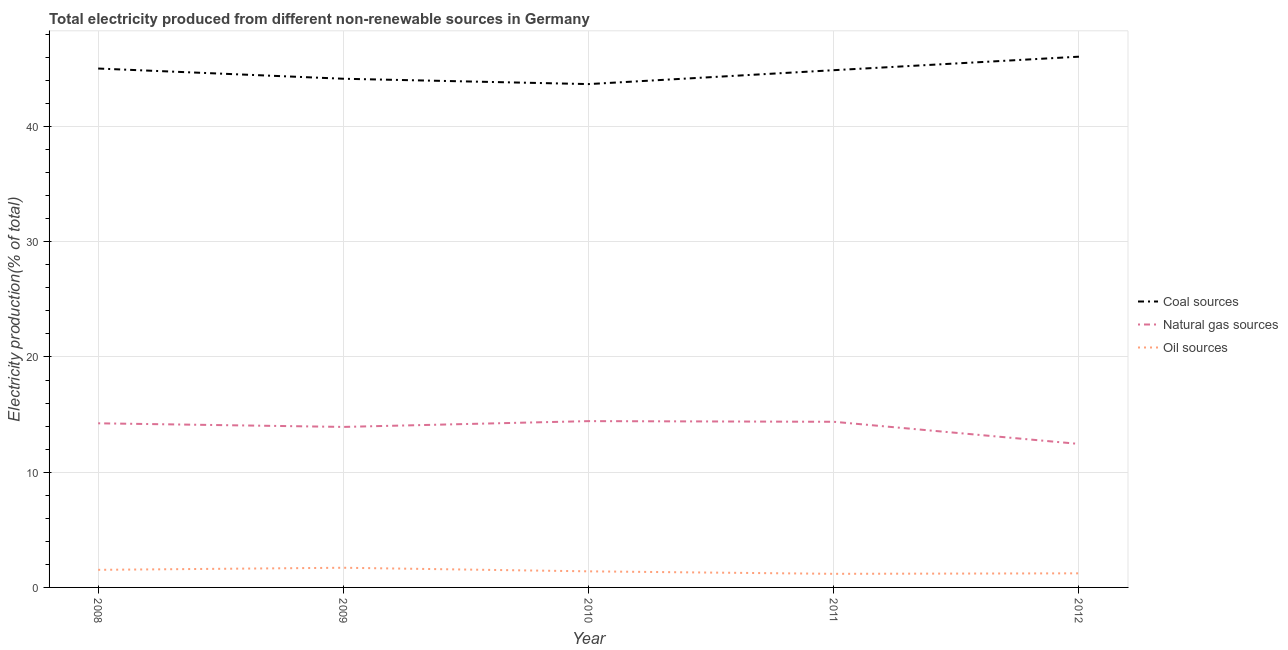Does the line corresponding to percentage of electricity produced by natural gas intersect with the line corresponding to percentage of electricity produced by oil sources?
Ensure brevity in your answer.  No. What is the percentage of electricity produced by natural gas in 2009?
Give a very brief answer. 13.93. Across all years, what is the maximum percentage of electricity produced by oil sources?
Provide a short and direct response. 1.71. Across all years, what is the minimum percentage of electricity produced by coal?
Keep it short and to the point. 43.68. In which year was the percentage of electricity produced by coal maximum?
Keep it short and to the point. 2012. What is the total percentage of electricity produced by natural gas in the graph?
Offer a very short reply. 69.43. What is the difference between the percentage of electricity produced by natural gas in 2009 and that in 2012?
Your answer should be very brief. 1.48. What is the difference between the percentage of electricity produced by coal in 2008 and the percentage of electricity produced by natural gas in 2009?
Keep it short and to the point. 31.1. What is the average percentage of electricity produced by coal per year?
Provide a succinct answer. 44.76. In the year 2012, what is the difference between the percentage of electricity produced by natural gas and percentage of electricity produced by coal?
Ensure brevity in your answer.  -33.6. What is the ratio of the percentage of electricity produced by coal in 2009 to that in 2010?
Your answer should be compact. 1.01. What is the difference between the highest and the second highest percentage of electricity produced by oil sources?
Keep it short and to the point. 0.18. What is the difference between the highest and the lowest percentage of electricity produced by natural gas?
Your response must be concise. 1.98. Is it the case that in every year, the sum of the percentage of electricity produced by coal and percentage of electricity produced by natural gas is greater than the percentage of electricity produced by oil sources?
Your answer should be very brief. Yes. How many years are there in the graph?
Make the answer very short. 5. What is the difference between two consecutive major ticks on the Y-axis?
Ensure brevity in your answer.  10. What is the title of the graph?
Offer a terse response. Total electricity produced from different non-renewable sources in Germany. Does "Services" appear as one of the legend labels in the graph?
Offer a very short reply. No. What is the label or title of the Y-axis?
Make the answer very short. Electricity production(% of total). What is the Electricity production(% of total) in Coal sources in 2008?
Offer a very short reply. 45.03. What is the Electricity production(% of total) of Natural gas sources in 2008?
Ensure brevity in your answer.  14.24. What is the Electricity production(% of total) of Oil sources in 2008?
Your answer should be very brief. 1.53. What is the Electricity production(% of total) of Coal sources in 2009?
Ensure brevity in your answer.  44.14. What is the Electricity production(% of total) in Natural gas sources in 2009?
Ensure brevity in your answer.  13.93. What is the Electricity production(% of total) in Oil sources in 2009?
Provide a succinct answer. 1.71. What is the Electricity production(% of total) in Coal sources in 2010?
Keep it short and to the point. 43.68. What is the Electricity production(% of total) in Natural gas sources in 2010?
Ensure brevity in your answer.  14.43. What is the Electricity production(% of total) in Oil sources in 2010?
Ensure brevity in your answer.  1.4. What is the Electricity production(% of total) in Coal sources in 2011?
Give a very brief answer. 44.89. What is the Electricity production(% of total) in Natural gas sources in 2011?
Provide a short and direct response. 14.37. What is the Electricity production(% of total) in Oil sources in 2011?
Your response must be concise. 1.18. What is the Electricity production(% of total) in Coal sources in 2012?
Give a very brief answer. 46.06. What is the Electricity production(% of total) in Natural gas sources in 2012?
Your answer should be very brief. 12.45. What is the Electricity production(% of total) in Oil sources in 2012?
Provide a short and direct response. 1.22. Across all years, what is the maximum Electricity production(% of total) of Coal sources?
Your answer should be compact. 46.06. Across all years, what is the maximum Electricity production(% of total) of Natural gas sources?
Provide a succinct answer. 14.43. Across all years, what is the maximum Electricity production(% of total) in Oil sources?
Offer a very short reply. 1.71. Across all years, what is the minimum Electricity production(% of total) in Coal sources?
Keep it short and to the point. 43.68. Across all years, what is the minimum Electricity production(% of total) of Natural gas sources?
Make the answer very short. 12.45. Across all years, what is the minimum Electricity production(% of total) in Oil sources?
Ensure brevity in your answer.  1.18. What is the total Electricity production(% of total) of Coal sources in the graph?
Your answer should be compact. 223.8. What is the total Electricity production(% of total) of Natural gas sources in the graph?
Your answer should be very brief. 69.43. What is the total Electricity production(% of total) in Oil sources in the graph?
Provide a succinct answer. 7.03. What is the difference between the Electricity production(% of total) of Coal sources in 2008 and that in 2009?
Provide a succinct answer. 0.89. What is the difference between the Electricity production(% of total) in Natural gas sources in 2008 and that in 2009?
Keep it short and to the point. 0.31. What is the difference between the Electricity production(% of total) of Oil sources in 2008 and that in 2009?
Offer a terse response. -0.18. What is the difference between the Electricity production(% of total) in Coal sources in 2008 and that in 2010?
Offer a very short reply. 1.35. What is the difference between the Electricity production(% of total) in Natural gas sources in 2008 and that in 2010?
Your answer should be very brief. -0.19. What is the difference between the Electricity production(% of total) of Oil sources in 2008 and that in 2010?
Keep it short and to the point. 0.13. What is the difference between the Electricity production(% of total) in Coal sources in 2008 and that in 2011?
Make the answer very short. 0.14. What is the difference between the Electricity production(% of total) of Natural gas sources in 2008 and that in 2011?
Your response must be concise. -0.13. What is the difference between the Electricity production(% of total) of Oil sources in 2008 and that in 2011?
Your response must be concise. 0.35. What is the difference between the Electricity production(% of total) in Coal sources in 2008 and that in 2012?
Make the answer very short. -1.03. What is the difference between the Electricity production(% of total) of Natural gas sources in 2008 and that in 2012?
Ensure brevity in your answer.  1.79. What is the difference between the Electricity production(% of total) of Oil sources in 2008 and that in 2012?
Offer a very short reply. 0.3. What is the difference between the Electricity production(% of total) in Coal sources in 2009 and that in 2010?
Your response must be concise. 0.46. What is the difference between the Electricity production(% of total) in Natural gas sources in 2009 and that in 2010?
Give a very brief answer. -0.5. What is the difference between the Electricity production(% of total) of Oil sources in 2009 and that in 2010?
Keep it short and to the point. 0.31. What is the difference between the Electricity production(% of total) of Coal sources in 2009 and that in 2011?
Offer a very short reply. -0.74. What is the difference between the Electricity production(% of total) in Natural gas sources in 2009 and that in 2011?
Provide a succinct answer. -0.45. What is the difference between the Electricity production(% of total) in Oil sources in 2009 and that in 2011?
Provide a short and direct response. 0.53. What is the difference between the Electricity production(% of total) of Coal sources in 2009 and that in 2012?
Keep it short and to the point. -1.91. What is the difference between the Electricity production(% of total) in Natural gas sources in 2009 and that in 2012?
Offer a very short reply. 1.48. What is the difference between the Electricity production(% of total) in Oil sources in 2009 and that in 2012?
Give a very brief answer. 0.48. What is the difference between the Electricity production(% of total) in Coal sources in 2010 and that in 2011?
Keep it short and to the point. -1.21. What is the difference between the Electricity production(% of total) of Natural gas sources in 2010 and that in 2011?
Provide a short and direct response. 0.06. What is the difference between the Electricity production(% of total) in Oil sources in 2010 and that in 2011?
Provide a short and direct response. 0.22. What is the difference between the Electricity production(% of total) in Coal sources in 2010 and that in 2012?
Make the answer very short. -2.38. What is the difference between the Electricity production(% of total) of Natural gas sources in 2010 and that in 2012?
Give a very brief answer. 1.98. What is the difference between the Electricity production(% of total) in Oil sources in 2010 and that in 2012?
Offer a terse response. 0.17. What is the difference between the Electricity production(% of total) in Coal sources in 2011 and that in 2012?
Your answer should be very brief. -1.17. What is the difference between the Electricity production(% of total) of Natural gas sources in 2011 and that in 2012?
Provide a short and direct response. 1.92. What is the difference between the Electricity production(% of total) of Oil sources in 2011 and that in 2012?
Offer a terse response. -0.04. What is the difference between the Electricity production(% of total) in Coal sources in 2008 and the Electricity production(% of total) in Natural gas sources in 2009?
Keep it short and to the point. 31.1. What is the difference between the Electricity production(% of total) in Coal sources in 2008 and the Electricity production(% of total) in Oil sources in 2009?
Keep it short and to the point. 43.32. What is the difference between the Electricity production(% of total) in Natural gas sources in 2008 and the Electricity production(% of total) in Oil sources in 2009?
Provide a succinct answer. 12.54. What is the difference between the Electricity production(% of total) in Coal sources in 2008 and the Electricity production(% of total) in Natural gas sources in 2010?
Offer a terse response. 30.6. What is the difference between the Electricity production(% of total) of Coal sources in 2008 and the Electricity production(% of total) of Oil sources in 2010?
Keep it short and to the point. 43.63. What is the difference between the Electricity production(% of total) in Natural gas sources in 2008 and the Electricity production(% of total) in Oil sources in 2010?
Make the answer very short. 12.85. What is the difference between the Electricity production(% of total) in Coal sources in 2008 and the Electricity production(% of total) in Natural gas sources in 2011?
Offer a terse response. 30.66. What is the difference between the Electricity production(% of total) of Coal sources in 2008 and the Electricity production(% of total) of Oil sources in 2011?
Give a very brief answer. 43.85. What is the difference between the Electricity production(% of total) in Natural gas sources in 2008 and the Electricity production(% of total) in Oil sources in 2011?
Ensure brevity in your answer.  13.06. What is the difference between the Electricity production(% of total) in Coal sources in 2008 and the Electricity production(% of total) in Natural gas sources in 2012?
Your answer should be very brief. 32.58. What is the difference between the Electricity production(% of total) in Coal sources in 2008 and the Electricity production(% of total) in Oil sources in 2012?
Ensure brevity in your answer.  43.81. What is the difference between the Electricity production(% of total) of Natural gas sources in 2008 and the Electricity production(% of total) of Oil sources in 2012?
Make the answer very short. 13.02. What is the difference between the Electricity production(% of total) in Coal sources in 2009 and the Electricity production(% of total) in Natural gas sources in 2010?
Keep it short and to the point. 29.71. What is the difference between the Electricity production(% of total) of Coal sources in 2009 and the Electricity production(% of total) of Oil sources in 2010?
Ensure brevity in your answer.  42.75. What is the difference between the Electricity production(% of total) in Natural gas sources in 2009 and the Electricity production(% of total) in Oil sources in 2010?
Provide a succinct answer. 12.53. What is the difference between the Electricity production(% of total) in Coal sources in 2009 and the Electricity production(% of total) in Natural gas sources in 2011?
Offer a very short reply. 29.77. What is the difference between the Electricity production(% of total) of Coal sources in 2009 and the Electricity production(% of total) of Oil sources in 2011?
Your response must be concise. 42.96. What is the difference between the Electricity production(% of total) in Natural gas sources in 2009 and the Electricity production(% of total) in Oil sources in 2011?
Ensure brevity in your answer.  12.75. What is the difference between the Electricity production(% of total) of Coal sources in 2009 and the Electricity production(% of total) of Natural gas sources in 2012?
Make the answer very short. 31.69. What is the difference between the Electricity production(% of total) in Coal sources in 2009 and the Electricity production(% of total) in Oil sources in 2012?
Provide a succinct answer. 42.92. What is the difference between the Electricity production(% of total) in Natural gas sources in 2009 and the Electricity production(% of total) in Oil sources in 2012?
Your response must be concise. 12.7. What is the difference between the Electricity production(% of total) of Coal sources in 2010 and the Electricity production(% of total) of Natural gas sources in 2011?
Give a very brief answer. 29.3. What is the difference between the Electricity production(% of total) in Coal sources in 2010 and the Electricity production(% of total) in Oil sources in 2011?
Make the answer very short. 42.5. What is the difference between the Electricity production(% of total) in Natural gas sources in 2010 and the Electricity production(% of total) in Oil sources in 2011?
Your answer should be compact. 13.25. What is the difference between the Electricity production(% of total) in Coal sources in 2010 and the Electricity production(% of total) in Natural gas sources in 2012?
Make the answer very short. 31.23. What is the difference between the Electricity production(% of total) in Coal sources in 2010 and the Electricity production(% of total) in Oil sources in 2012?
Offer a very short reply. 42.46. What is the difference between the Electricity production(% of total) in Natural gas sources in 2010 and the Electricity production(% of total) in Oil sources in 2012?
Your answer should be compact. 13.21. What is the difference between the Electricity production(% of total) of Coal sources in 2011 and the Electricity production(% of total) of Natural gas sources in 2012?
Keep it short and to the point. 32.43. What is the difference between the Electricity production(% of total) in Coal sources in 2011 and the Electricity production(% of total) in Oil sources in 2012?
Ensure brevity in your answer.  43.66. What is the difference between the Electricity production(% of total) in Natural gas sources in 2011 and the Electricity production(% of total) in Oil sources in 2012?
Keep it short and to the point. 13.15. What is the average Electricity production(% of total) in Coal sources per year?
Your answer should be very brief. 44.76. What is the average Electricity production(% of total) in Natural gas sources per year?
Give a very brief answer. 13.89. What is the average Electricity production(% of total) in Oil sources per year?
Give a very brief answer. 1.41. In the year 2008, what is the difference between the Electricity production(% of total) in Coal sources and Electricity production(% of total) in Natural gas sources?
Your response must be concise. 30.79. In the year 2008, what is the difference between the Electricity production(% of total) of Coal sources and Electricity production(% of total) of Oil sources?
Offer a terse response. 43.5. In the year 2008, what is the difference between the Electricity production(% of total) in Natural gas sources and Electricity production(% of total) in Oil sources?
Your answer should be very brief. 12.72. In the year 2009, what is the difference between the Electricity production(% of total) in Coal sources and Electricity production(% of total) in Natural gas sources?
Ensure brevity in your answer.  30.21. In the year 2009, what is the difference between the Electricity production(% of total) of Coal sources and Electricity production(% of total) of Oil sources?
Offer a very short reply. 42.44. In the year 2009, what is the difference between the Electricity production(% of total) of Natural gas sources and Electricity production(% of total) of Oil sources?
Your answer should be compact. 12.22. In the year 2010, what is the difference between the Electricity production(% of total) of Coal sources and Electricity production(% of total) of Natural gas sources?
Keep it short and to the point. 29.25. In the year 2010, what is the difference between the Electricity production(% of total) in Coal sources and Electricity production(% of total) in Oil sources?
Your answer should be very brief. 42.28. In the year 2010, what is the difference between the Electricity production(% of total) of Natural gas sources and Electricity production(% of total) of Oil sources?
Your answer should be very brief. 13.04. In the year 2011, what is the difference between the Electricity production(% of total) in Coal sources and Electricity production(% of total) in Natural gas sources?
Your answer should be compact. 30.51. In the year 2011, what is the difference between the Electricity production(% of total) in Coal sources and Electricity production(% of total) in Oil sources?
Provide a succinct answer. 43.71. In the year 2011, what is the difference between the Electricity production(% of total) in Natural gas sources and Electricity production(% of total) in Oil sources?
Give a very brief answer. 13.19. In the year 2012, what is the difference between the Electricity production(% of total) of Coal sources and Electricity production(% of total) of Natural gas sources?
Provide a short and direct response. 33.6. In the year 2012, what is the difference between the Electricity production(% of total) in Coal sources and Electricity production(% of total) in Oil sources?
Make the answer very short. 44.83. In the year 2012, what is the difference between the Electricity production(% of total) in Natural gas sources and Electricity production(% of total) in Oil sources?
Make the answer very short. 11.23. What is the ratio of the Electricity production(% of total) in Coal sources in 2008 to that in 2009?
Keep it short and to the point. 1.02. What is the ratio of the Electricity production(% of total) in Natural gas sources in 2008 to that in 2009?
Keep it short and to the point. 1.02. What is the ratio of the Electricity production(% of total) in Oil sources in 2008 to that in 2009?
Provide a short and direct response. 0.89. What is the ratio of the Electricity production(% of total) of Coal sources in 2008 to that in 2010?
Keep it short and to the point. 1.03. What is the ratio of the Electricity production(% of total) in Natural gas sources in 2008 to that in 2010?
Your answer should be very brief. 0.99. What is the ratio of the Electricity production(% of total) of Oil sources in 2008 to that in 2010?
Provide a succinct answer. 1.09. What is the ratio of the Electricity production(% of total) in Coal sources in 2008 to that in 2011?
Give a very brief answer. 1. What is the ratio of the Electricity production(% of total) of Oil sources in 2008 to that in 2011?
Ensure brevity in your answer.  1.29. What is the ratio of the Electricity production(% of total) in Coal sources in 2008 to that in 2012?
Provide a short and direct response. 0.98. What is the ratio of the Electricity production(% of total) in Natural gas sources in 2008 to that in 2012?
Offer a terse response. 1.14. What is the ratio of the Electricity production(% of total) of Oil sources in 2008 to that in 2012?
Offer a very short reply. 1.25. What is the ratio of the Electricity production(% of total) in Coal sources in 2009 to that in 2010?
Your answer should be compact. 1.01. What is the ratio of the Electricity production(% of total) of Natural gas sources in 2009 to that in 2010?
Ensure brevity in your answer.  0.97. What is the ratio of the Electricity production(% of total) of Oil sources in 2009 to that in 2010?
Offer a terse response. 1.22. What is the ratio of the Electricity production(% of total) in Coal sources in 2009 to that in 2011?
Make the answer very short. 0.98. What is the ratio of the Electricity production(% of total) of Natural gas sources in 2009 to that in 2011?
Offer a terse response. 0.97. What is the ratio of the Electricity production(% of total) in Oil sources in 2009 to that in 2011?
Offer a very short reply. 1.45. What is the ratio of the Electricity production(% of total) in Coal sources in 2009 to that in 2012?
Provide a short and direct response. 0.96. What is the ratio of the Electricity production(% of total) of Natural gas sources in 2009 to that in 2012?
Your response must be concise. 1.12. What is the ratio of the Electricity production(% of total) in Oil sources in 2009 to that in 2012?
Ensure brevity in your answer.  1.4. What is the ratio of the Electricity production(% of total) of Coal sources in 2010 to that in 2011?
Your answer should be very brief. 0.97. What is the ratio of the Electricity production(% of total) of Natural gas sources in 2010 to that in 2011?
Your answer should be very brief. 1. What is the ratio of the Electricity production(% of total) in Oil sources in 2010 to that in 2011?
Your response must be concise. 1.18. What is the ratio of the Electricity production(% of total) of Coal sources in 2010 to that in 2012?
Keep it short and to the point. 0.95. What is the ratio of the Electricity production(% of total) of Natural gas sources in 2010 to that in 2012?
Make the answer very short. 1.16. What is the ratio of the Electricity production(% of total) of Oil sources in 2010 to that in 2012?
Make the answer very short. 1.14. What is the ratio of the Electricity production(% of total) in Coal sources in 2011 to that in 2012?
Ensure brevity in your answer.  0.97. What is the ratio of the Electricity production(% of total) of Natural gas sources in 2011 to that in 2012?
Make the answer very short. 1.15. What is the difference between the highest and the second highest Electricity production(% of total) in Coal sources?
Offer a very short reply. 1.03. What is the difference between the highest and the second highest Electricity production(% of total) in Natural gas sources?
Provide a short and direct response. 0.06. What is the difference between the highest and the second highest Electricity production(% of total) in Oil sources?
Ensure brevity in your answer.  0.18. What is the difference between the highest and the lowest Electricity production(% of total) in Coal sources?
Your response must be concise. 2.38. What is the difference between the highest and the lowest Electricity production(% of total) of Natural gas sources?
Provide a succinct answer. 1.98. What is the difference between the highest and the lowest Electricity production(% of total) of Oil sources?
Provide a succinct answer. 0.53. 